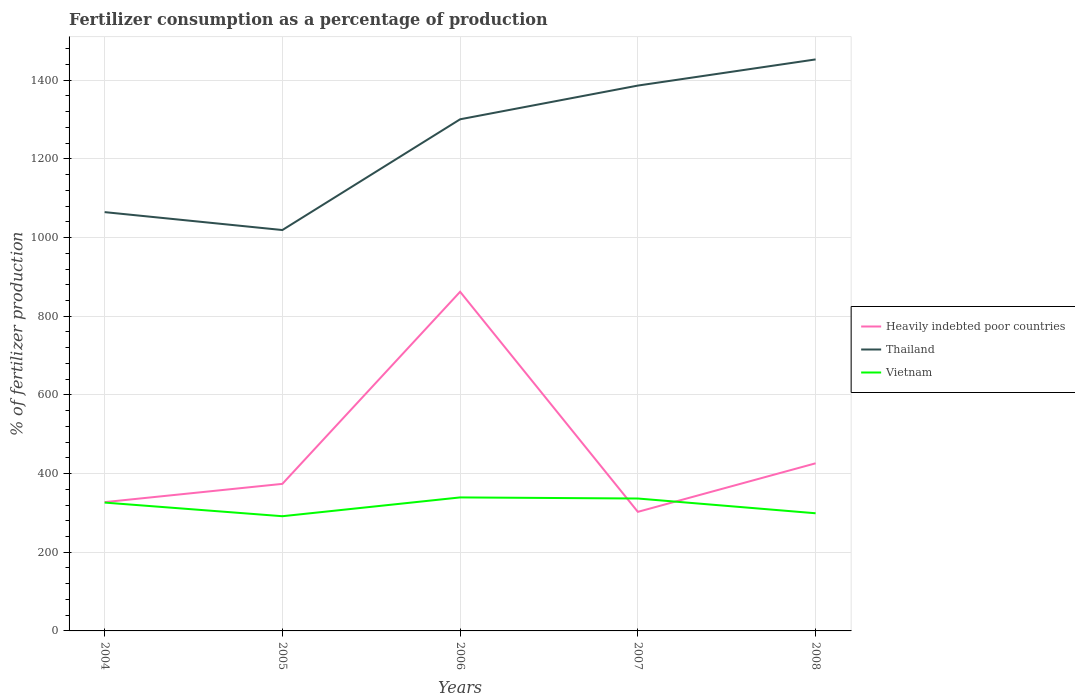How many different coloured lines are there?
Give a very brief answer. 3. Does the line corresponding to Thailand intersect with the line corresponding to Heavily indebted poor countries?
Make the answer very short. No. Across all years, what is the maximum percentage of fertilizers consumed in Heavily indebted poor countries?
Provide a succinct answer. 302.7. In which year was the percentage of fertilizers consumed in Vietnam maximum?
Your answer should be very brief. 2005. What is the total percentage of fertilizers consumed in Thailand in the graph?
Offer a terse response. -433.73. What is the difference between the highest and the second highest percentage of fertilizers consumed in Vietnam?
Provide a succinct answer. 47.77. What is the difference between the highest and the lowest percentage of fertilizers consumed in Heavily indebted poor countries?
Your answer should be very brief. 1. How many lines are there?
Your response must be concise. 3. Does the graph contain grids?
Your answer should be very brief. Yes. How many legend labels are there?
Provide a succinct answer. 3. What is the title of the graph?
Keep it short and to the point. Fertilizer consumption as a percentage of production. What is the label or title of the X-axis?
Keep it short and to the point. Years. What is the label or title of the Y-axis?
Make the answer very short. % of fertilizer production. What is the % of fertilizer production of Heavily indebted poor countries in 2004?
Your response must be concise. 327.38. What is the % of fertilizer production of Thailand in 2004?
Provide a short and direct response. 1064.63. What is the % of fertilizer production of Vietnam in 2004?
Your response must be concise. 326.27. What is the % of fertilizer production of Heavily indebted poor countries in 2005?
Provide a short and direct response. 373.84. What is the % of fertilizer production of Thailand in 2005?
Give a very brief answer. 1019.11. What is the % of fertilizer production of Vietnam in 2005?
Provide a short and direct response. 291.61. What is the % of fertilizer production of Heavily indebted poor countries in 2006?
Ensure brevity in your answer.  862.17. What is the % of fertilizer production in Thailand in 2006?
Make the answer very short. 1300.64. What is the % of fertilizer production of Vietnam in 2006?
Provide a short and direct response. 339.37. What is the % of fertilizer production in Heavily indebted poor countries in 2007?
Offer a terse response. 302.7. What is the % of fertilizer production of Thailand in 2007?
Offer a very short reply. 1386.34. What is the % of fertilizer production in Vietnam in 2007?
Provide a short and direct response. 336.59. What is the % of fertilizer production of Heavily indebted poor countries in 2008?
Your answer should be compact. 426.11. What is the % of fertilizer production in Thailand in 2008?
Provide a short and direct response. 1452.84. What is the % of fertilizer production of Vietnam in 2008?
Offer a very short reply. 299.09. Across all years, what is the maximum % of fertilizer production in Heavily indebted poor countries?
Your answer should be very brief. 862.17. Across all years, what is the maximum % of fertilizer production in Thailand?
Give a very brief answer. 1452.84. Across all years, what is the maximum % of fertilizer production in Vietnam?
Make the answer very short. 339.37. Across all years, what is the minimum % of fertilizer production in Heavily indebted poor countries?
Offer a terse response. 302.7. Across all years, what is the minimum % of fertilizer production of Thailand?
Your answer should be compact. 1019.11. Across all years, what is the minimum % of fertilizer production in Vietnam?
Keep it short and to the point. 291.61. What is the total % of fertilizer production in Heavily indebted poor countries in the graph?
Provide a short and direct response. 2292.2. What is the total % of fertilizer production of Thailand in the graph?
Give a very brief answer. 6223.56. What is the total % of fertilizer production of Vietnam in the graph?
Make the answer very short. 1592.93. What is the difference between the % of fertilizer production of Heavily indebted poor countries in 2004 and that in 2005?
Offer a very short reply. -46.46. What is the difference between the % of fertilizer production of Thailand in 2004 and that in 2005?
Give a very brief answer. 45.52. What is the difference between the % of fertilizer production in Vietnam in 2004 and that in 2005?
Provide a short and direct response. 34.66. What is the difference between the % of fertilizer production of Heavily indebted poor countries in 2004 and that in 2006?
Your response must be concise. -534.78. What is the difference between the % of fertilizer production in Thailand in 2004 and that in 2006?
Ensure brevity in your answer.  -236.01. What is the difference between the % of fertilizer production of Vietnam in 2004 and that in 2006?
Offer a terse response. -13.11. What is the difference between the % of fertilizer production of Heavily indebted poor countries in 2004 and that in 2007?
Your answer should be compact. 24.69. What is the difference between the % of fertilizer production of Thailand in 2004 and that in 2007?
Make the answer very short. -321.71. What is the difference between the % of fertilizer production in Vietnam in 2004 and that in 2007?
Give a very brief answer. -10.32. What is the difference between the % of fertilizer production of Heavily indebted poor countries in 2004 and that in 2008?
Give a very brief answer. -98.72. What is the difference between the % of fertilizer production in Thailand in 2004 and that in 2008?
Your response must be concise. -388.21. What is the difference between the % of fertilizer production in Vietnam in 2004 and that in 2008?
Give a very brief answer. 27.18. What is the difference between the % of fertilizer production of Heavily indebted poor countries in 2005 and that in 2006?
Your answer should be compact. -488.32. What is the difference between the % of fertilizer production of Thailand in 2005 and that in 2006?
Ensure brevity in your answer.  -281.53. What is the difference between the % of fertilizer production in Vietnam in 2005 and that in 2006?
Your response must be concise. -47.77. What is the difference between the % of fertilizer production in Heavily indebted poor countries in 2005 and that in 2007?
Ensure brevity in your answer.  71.14. What is the difference between the % of fertilizer production in Thailand in 2005 and that in 2007?
Offer a very short reply. -367.23. What is the difference between the % of fertilizer production in Vietnam in 2005 and that in 2007?
Make the answer very short. -44.98. What is the difference between the % of fertilizer production of Heavily indebted poor countries in 2005 and that in 2008?
Provide a succinct answer. -52.27. What is the difference between the % of fertilizer production in Thailand in 2005 and that in 2008?
Provide a short and direct response. -433.73. What is the difference between the % of fertilizer production in Vietnam in 2005 and that in 2008?
Offer a very short reply. -7.48. What is the difference between the % of fertilizer production of Heavily indebted poor countries in 2006 and that in 2007?
Offer a very short reply. 559.47. What is the difference between the % of fertilizer production in Thailand in 2006 and that in 2007?
Your response must be concise. -85.7. What is the difference between the % of fertilizer production in Vietnam in 2006 and that in 2007?
Give a very brief answer. 2.79. What is the difference between the % of fertilizer production of Heavily indebted poor countries in 2006 and that in 2008?
Provide a short and direct response. 436.06. What is the difference between the % of fertilizer production of Thailand in 2006 and that in 2008?
Offer a terse response. -152.2. What is the difference between the % of fertilizer production in Vietnam in 2006 and that in 2008?
Your answer should be compact. 40.28. What is the difference between the % of fertilizer production of Heavily indebted poor countries in 2007 and that in 2008?
Your response must be concise. -123.41. What is the difference between the % of fertilizer production of Thailand in 2007 and that in 2008?
Offer a terse response. -66.5. What is the difference between the % of fertilizer production in Vietnam in 2007 and that in 2008?
Give a very brief answer. 37.5. What is the difference between the % of fertilizer production in Heavily indebted poor countries in 2004 and the % of fertilizer production in Thailand in 2005?
Your answer should be compact. -691.73. What is the difference between the % of fertilizer production in Heavily indebted poor countries in 2004 and the % of fertilizer production in Vietnam in 2005?
Provide a succinct answer. 35.78. What is the difference between the % of fertilizer production of Thailand in 2004 and the % of fertilizer production of Vietnam in 2005?
Your answer should be very brief. 773.02. What is the difference between the % of fertilizer production in Heavily indebted poor countries in 2004 and the % of fertilizer production in Thailand in 2006?
Give a very brief answer. -973.26. What is the difference between the % of fertilizer production in Heavily indebted poor countries in 2004 and the % of fertilizer production in Vietnam in 2006?
Provide a succinct answer. -11.99. What is the difference between the % of fertilizer production of Thailand in 2004 and the % of fertilizer production of Vietnam in 2006?
Your answer should be compact. 725.25. What is the difference between the % of fertilizer production in Heavily indebted poor countries in 2004 and the % of fertilizer production in Thailand in 2007?
Your answer should be very brief. -1058.95. What is the difference between the % of fertilizer production of Heavily indebted poor countries in 2004 and the % of fertilizer production of Vietnam in 2007?
Keep it short and to the point. -9.21. What is the difference between the % of fertilizer production in Thailand in 2004 and the % of fertilizer production in Vietnam in 2007?
Provide a succinct answer. 728.04. What is the difference between the % of fertilizer production of Heavily indebted poor countries in 2004 and the % of fertilizer production of Thailand in 2008?
Provide a short and direct response. -1125.46. What is the difference between the % of fertilizer production in Heavily indebted poor countries in 2004 and the % of fertilizer production in Vietnam in 2008?
Offer a very short reply. 28.29. What is the difference between the % of fertilizer production of Thailand in 2004 and the % of fertilizer production of Vietnam in 2008?
Keep it short and to the point. 765.54. What is the difference between the % of fertilizer production in Heavily indebted poor countries in 2005 and the % of fertilizer production in Thailand in 2006?
Your answer should be very brief. -926.8. What is the difference between the % of fertilizer production in Heavily indebted poor countries in 2005 and the % of fertilizer production in Vietnam in 2006?
Keep it short and to the point. 34.47. What is the difference between the % of fertilizer production of Thailand in 2005 and the % of fertilizer production of Vietnam in 2006?
Provide a short and direct response. 679.74. What is the difference between the % of fertilizer production of Heavily indebted poor countries in 2005 and the % of fertilizer production of Thailand in 2007?
Offer a very short reply. -1012.5. What is the difference between the % of fertilizer production of Heavily indebted poor countries in 2005 and the % of fertilizer production of Vietnam in 2007?
Offer a terse response. 37.25. What is the difference between the % of fertilizer production of Thailand in 2005 and the % of fertilizer production of Vietnam in 2007?
Your answer should be compact. 682.52. What is the difference between the % of fertilizer production of Heavily indebted poor countries in 2005 and the % of fertilizer production of Thailand in 2008?
Make the answer very short. -1079. What is the difference between the % of fertilizer production in Heavily indebted poor countries in 2005 and the % of fertilizer production in Vietnam in 2008?
Give a very brief answer. 74.75. What is the difference between the % of fertilizer production in Thailand in 2005 and the % of fertilizer production in Vietnam in 2008?
Provide a succinct answer. 720.02. What is the difference between the % of fertilizer production of Heavily indebted poor countries in 2006 and the % of fertilizer production of Thailand in 2007?
Ensure brevity in your answer.  -524.17. What is the difference between the % of fertilizer production in Heavily indebted poor countries in 2006 and the % of fertilizer production in Vietnam in 2007?
Provide a succinct answer. 525.58. What is the difference between the % of fertilizer production of Thailand in 2006 and the % of fertilizer production of Vietnam in 2007?
Make the answer very short. 964.05. What is the difference between the % of fertilizer production of Heavily indebted poor countries in 2006 and the % of fertilizer production of Thailand in 2008?
Give a very brief answer. -590.68. What is the difference between the % of fertilizer production of Heavily indebted poor countries in 2006 and the % of fertilizer production of Vietnam in 2008?
Your answer should be very brief. 563.08. What is the difference between the % of fertilizer production in Thailand in 2006 and the % of fertilizer production in Vietnam in 2008?
Your response must be concise. 1001.55. What is the difference between the % of fertilizer production in Heavily indebted poor countries in 2007 and the % of fertilizer production in Thailand in 2008?
Make the answer very short. -1150.14. What is the difference between the % of fertilizer production in Heavily indebted poor countries in 2007 and the % of fertilizer production in Vietnam in 2008?
Provide a short and direct response. 3.61. What is the difference between the % of fertilizer production of Thailand in 2007 and the % of fertilizer production of Vietnam in 2008?
Offer a very short reply. 1087.25. What is the average % of fertilizer production of Heavily indebted poor countries per year?
Provide a short and direct response. 458.44. What is the average % of fertilizer production of Thailand per year?
Your answer should be compact. 1244.71. What is the average % of fertilizer production of Vietnam per year?
Offer a terse response. 318.59. In the year 2004, what is the difference between the % of fertilizer production in Heavily indebted poor countries and % of fertilizer production in Thailand?
Offer a very short reply. -737.24. In the year 2004, what is the difference between the % of fertilizer production in Heavily indebted poor countries and % of fertilizer production in Vietnam?
Provide a succinct answer. 1.12. In the year 2004, what is the difference between the % of fertilizer production in Thailand and % of fertilizer production in Vietnam?
Give a very brief answer. 738.36. In the year 2005, what is the difference between the % of fertilizer production of Heavily indebted poor countries and % of fertilizer production of Thailand?
Offer a terse response. -645.27. In the year 2005, what is the difference between the % of fertilizer production in Heavily indebted poor countries and % of fertilizer production in Vietnam?
Make the answer very short. 82.23. In the year 2005, what is the difference between the % of fertilizer production of Thailand and % of fertilizer production of Vietnam?
Your response must be concise. 727.5. In the year 2006, what is the difference between the % of fertilizer production in Heavily indebted poor countries and % of fertilizer production in Thailand?
Offer a very short reply. -438.47. In the year 2006, what is the difference between the % of fertilizer production in Heavily indebted poor countries and % of fertilizer production in Vietnam?
Your answer should be very brief. 522.79. In the year 2006, what is the difference between the % of fertilizer production in Thailand and % of fertilizer production in Vietnam?
Offer a terse response. 961.27. In the year 2007, what is the difference between the % of fertilizer production of Heavily indebted poor countries and % of fertilizer production of Thailand?
Your response must be concise. -1083.64. In the year 2007, what is the difference between the % of fertilizer production of Heavily indebted poor countries and % of fertilizer production of Vietnam?
Your answer should be very brief. -33.89. In the year 2007, what is the difference between the % of fertilizer production in Thailand and % of fertilizer production in Vietnam?
Your answer should be very brief. 1049.75. In the year 2008, what is the difference between the % of fertilizer production of Heavily indebted poor countries and % of fertilizer production of Thailand?
Your response must be concise. -1026.73. In the year 2008, what is the difference between the % of fertilizer production of Heavily indebted poor countries and % of fertilizer production of Vietnam?
Offer a very short reply. 127.02. In the year 2008, what is the difference between the % of fertilizer production in Thailand and % of fertilizer production in Vietnam?
Ensure brevity in your answer.  1153.75. What is the ratio of the % of fertilizer production in Heavily indebted poor countries in 2004 to that in 2005?
Offer a very short reply. 0.88. What is the ratio of the % of fertilizer production in Thailand in 2004 to that in 2005?
Provide a succinct answer. 1.04. What is the ratio of the % of fertilizer production of Vietnam in 2004 to that in 2005?
Offer a very short reply. 1.12. What is the ratio of the % of fertilizer production of Heavily indebted poor countries in 2004 to that in 2006?
Offer a terse response. 0.38. What is the ratio of the % of fertilizer production in Thailand in 2004 to that in 2006?
Ensure brevity in your answer.  0.82. What is the ratio of the % of fertilizer production in Vietnam in 2004 to that in 2006?
Offer a terse response. 0.96. What is the ratio of the % of fertilizer production of Heavily indebted poor countries in 2004 to that in 2007?
Give a very brief answer. 1.08. What is the ratio of the % of fertilizer production of Thailand in 2004 to that in 2007?
Keep it short and to the point. 0.77. What is the ratio of the % of fertilizer production of Vietnam in 2004 to that in 2007?
Provide a succinct answer. 0.97. What is the ratio of the % of fertilizer production in Heavily indebted poor countries in 2004 to that in 2008?
Keep it short and to the point. 0.77. What is the ratio of the % of fertilizer production in Thailand in 2004 to that in 2008?
Offer a very short reply. 0.73. What is the ratio of the % of fertilizer production in Vietnam in 2004 to that in 2008?
Your answer should be compact. 1.09. What is the ratio of the % of fertilizer production of Heavily indebted poor countries in 2005 to that in 2006?
Offer a terse response. 0.43. What is the ratio of the % of fertilizer production of Thailand in 2005 to that in 2006?
Offer a terse response. 0.78. What is the ratio of the % of fertilizer production of Vietnam in 2005 to that in 2006?
Your answer should be very brief. 0.86. What is the ratio of the % of fertilizer production in Heavily indebted poor countries in 2005 to that in 2007?
Your answer should be compact. 1.24. What is the ratio of the % of fertilizer production in Thailand in 2005 to that in 2007?
Give a very brief answer. 0.74. What is the ratio of the % of fertilizer production in Vietnam in 2005 to that in 2007?
Offer a very short reply. 0.87. What is the ratio of the % of fertilizer production in Heavily indebted poor countries in 2005 to that in 2008?
Provide a short and direct response. 0.88. What is the ratio of the % of fertilizer production of Thailand in 2005 to that in 2008?
Your answer should be very brief. 0.7. What is the ratio of the % of fertilizer production in Heavily indebted poor countries in 2006 to that in 2007?
Your answer should be compact. 2.85. What is the ratio of the % of fertilizer production of Thailand in 2006 to that in 2007?
Your response must be concise. 0.94. What is the ratio of the % of fertilizer production in Vietnam in 2006 to that in 2007?
Offer a terse response. 1.01. What is the ratio of the % of fertilizer production of Heavily indebted poor countries in 2006 to that in 2008?
Make the answer very short. 2.02. What is the ratio of the % of fertilizer production in Thailand in 2006 to that in 2008?
Give a very brief answer. 0.9. What is the ratio of the % of fertilizer production of Vietnam in 2006 to that in 2008?
Ensure brevity in your answer.  1.13. What is the ratio of the % of fertilizer production in Heavily indebted poor countries in 2007 to that in 2008?
Your response must be concise. 0.71. What is the ratio of the % of fertilizer production in Thailand in 2007 to that in 2008?
Provide a succinct answer. 0.95. What is the ratio of the % of fertilizer production in Vietnam in 2007 to that in 2008?
Your response must be concise. 1.13. What is the difference between the highest and the second highest % of fertilizer production of Heavily indebted poor countries?
Your answer should be compact. 436.06. What is the difference between the highest and the second highest % of fertilizer production in Thailand?
Your answer should be compact. 66.5. What is the difference between the highest and the second highest % of fertilizer production in Vietnam?
Your answer should be compact. 2.79. What is the difference between the highest and the lowest % of fertilizer production of Heavily indebted poor countries?
Keep it short and to the point. 559.47. What is the difference between the highest and the lowest % of fertilizer production in Thailand?
Provide a short and direct response. 433.73. What is the difference between the highest and the lowest % of fertilizer production in Vietnam?
Provide a short and direct response. 47.77. 